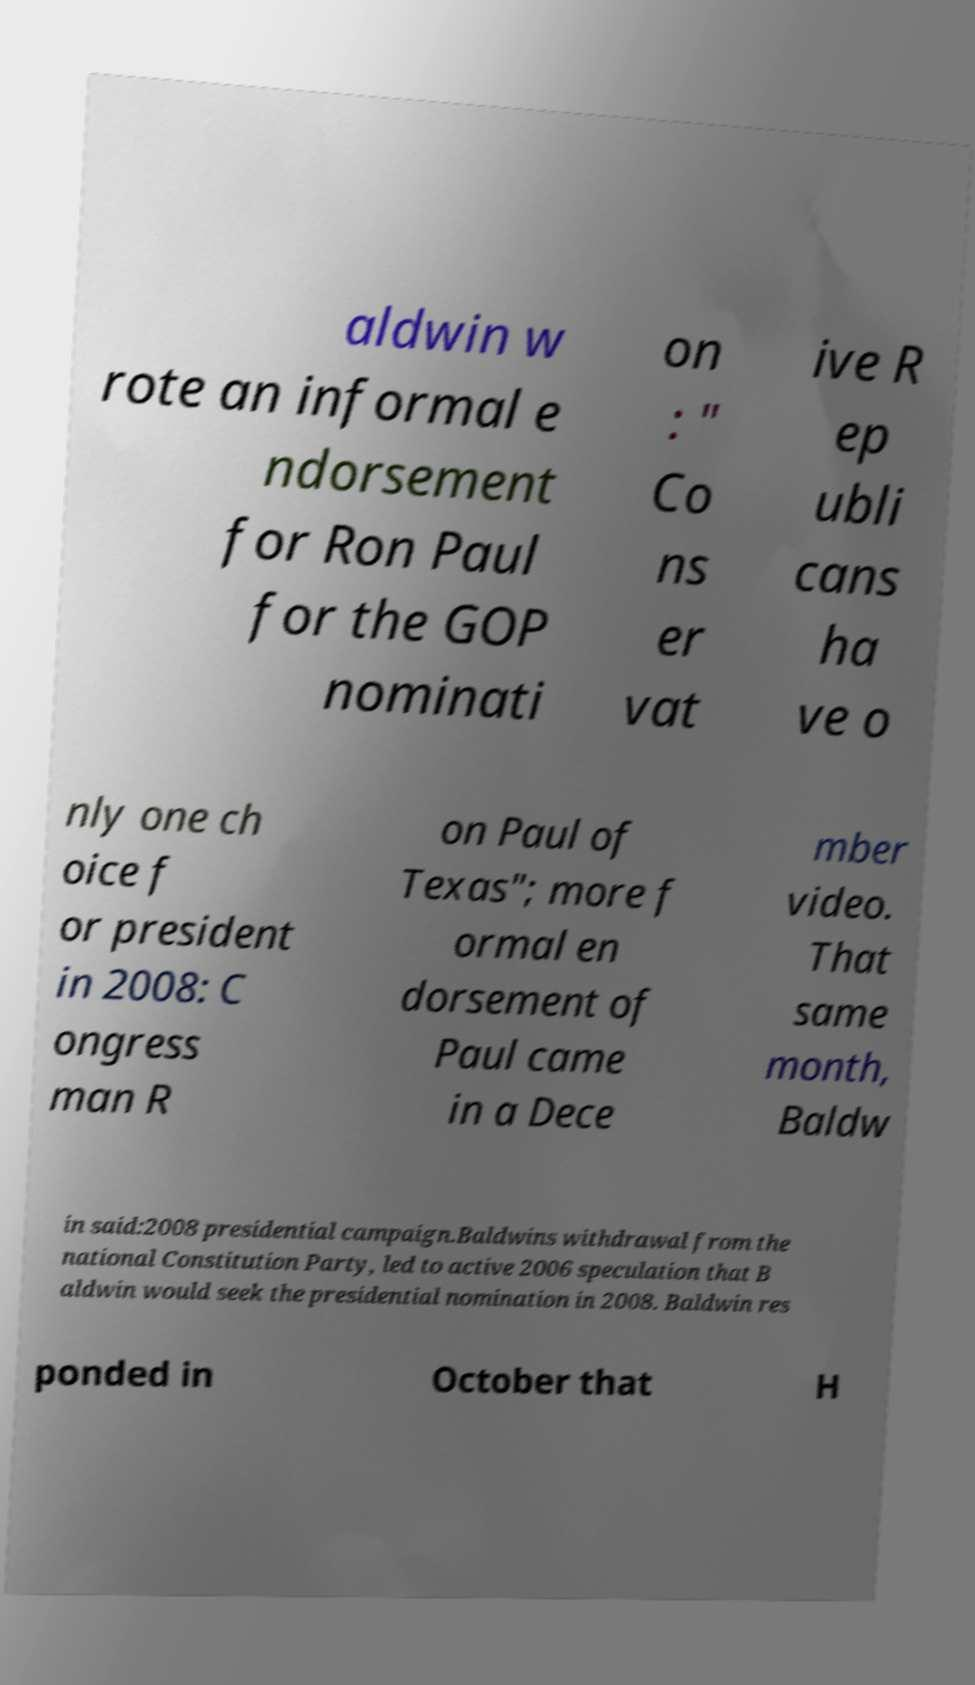Could you assist in decoding the text presented in this image and type it out clearly? aldwin w rote an informal e ndorsement for Ron Paul for the GOP nominati on : " Co ns er vat ive R ep ubli cans ha ve o nly one ch oice f or president in 2008: C ongress man R on Paul of Texas"; more f ormal en dorsement of Paul came in a Dece mber video. That same month, Baldw in said:2008 presidential campaign.Baldwins withdrawal from the national Constitution Party, led to active 2006 speculation that B aldwin would seek the presidential nomination in 2008. Baldwin res ponded in October that H 